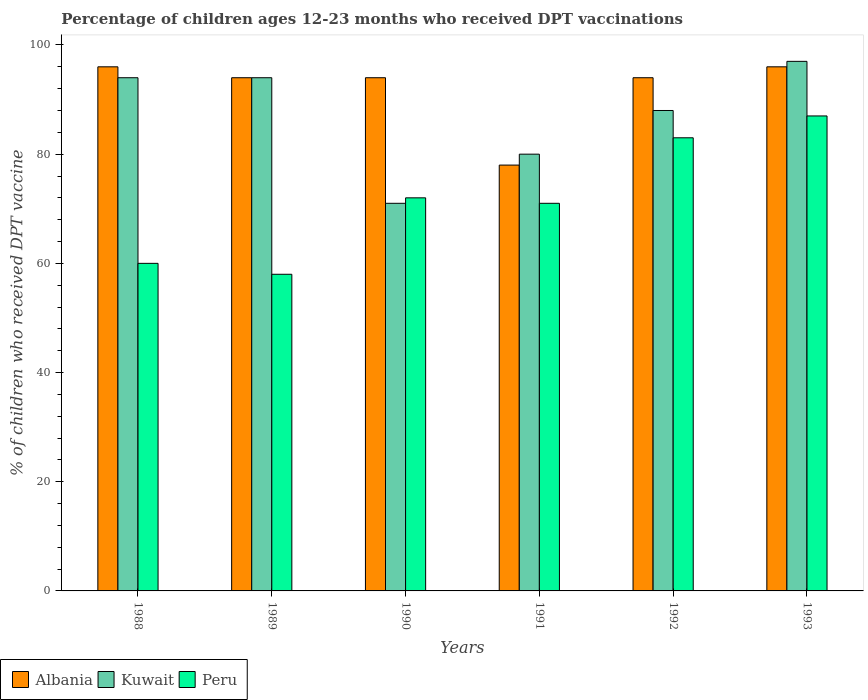How many different coloured bars are there?
Offer a very short reply. 3. How many groups of bars are there?
Offer a very short reply. 6. Are the number of bars per tick equal to the number of legend labels?
Your answer should be compact. Yes. Are the number of bars on each tick of the X-axis equal?
Ensure brevity in your answer.  Yes. How many bars are there on the 4th tick from the right?
Your response must be concise. 3. What is the label of the 1st group of bars from the left?
Keep it short and to the point. 1988. What is the percentage of children who received DPT vaccination in Albania in 1990?
Provide a succinct answer. 94. Across all years, what is the maximum percentage of children who received DPT vaccination in Peru?
Provide a succinct answer. 87. Across all years, what is the minimum percentage of children who received DPT vaccination in Albania?
Offer a terse response. 78. In which year was the percentage of children who received DPT vaccination in Albania maximum?
Offer a very short reply. 1988. In which year was the percentage of children who received DPT vaccination in Albania minimum?
Your answer should be very brief. 1991. What is the total percentage of children who received DPT vaccination in Albania in the graph?
Provide a succinct answer. 552. What is the difference between the percentage of children who received DPT vaccination in Kuwait in 1988 and the percentage of children who received DPT vaccination in Peru in 1990?
Give a very brief answer. 22. What is the average percentage of children who received DPT vaccination in Albania per year?
Provide a succinct answer. 92. In the year 1989, what is the difference between the percentage of children who received DPT vaccination in Albania and percentage of children who received DPT vaccination in Peru?
Give a very brief answer. 36. What is the ratio of the percentage of children who received DPT vaccination in Albania in 1991 to that in 1993?
Give a very brief answer. 0.81. Is the percentage of children who received DPT vaccination in Kuwait in 1990 less than that in 1992?
Provide a succinct answer. Yes. Is the difference between the percentage of children who received DPT vaccination in Albania in 1990 and 1992 greater than the difference between the percentage of children who received DPT vaccination in Peru in 1990 and 1992?
Offer a terse response. Yes. What is the difference between the highest and the second highest percentage of children who received DPT vaccination in Kuwait?
Offer a terse response. 3. What is the difference between the highest and the lowest percentage of children who received DPT vaccination in Kuwait?
Your response must be concise. 26. In how many years, is the percentage of children who received DPT vaccination in Peru greater than the average percentage of children who received DPT vaccination in Peru taken over all years?
Give a very brief answer. 3. Is the sum of the percentage of children who received DPT vaccination in Peru in 1988 and 1992 greater than the maximum percentage of children who received DPT vaccination in Albania across all years?
Provide a succinct answer. Yes. What does the 2nd bar from the right in 1988 represents?
Ensure brevity in your answer.  Kuwait. Is it the case that in every year, the sum of the percentage of children who received DPT vaccination in Kuwait and percentage of children who received DPT vaccination in Albania is greater than the percentage of children who received DPT vaccination in Peru?
Provide a short and direct response. Yes. How many years are there in the graph?
Give a very brief answer. 6. What is the difference between two consecutive major ticks on the Y-axis?
Provide a short and direct response. 20. Are the values on the major ticks of Y-axis written in scientific E-notation?
Your response must be concise. No. Does the graph contain any zero values?
Give a very brief answer. No. How are the legend labels stacked?
Ensure brevity in your answer.  Horizontal. What is the title of the graph?
Your response must be concise. Percentage of children ages 12-23 months who received DPT vaccinations. Does "Puerto Rico" appear as one of the legend labels in the graph?
Make the answer very short. No. What is the label or title of the X-axis?
Ensure brevity in your answer.  Years. What is the label or title of the Y-axis?
Offer a very short reply. % of children who received DPT vaccine. What is the % of children who received DPT vaccine of Albania in 1988?
Your response must be concise. 96. What is the % of children who received DPT vaccine in Kuwait in 1988?
Your answer should be compact. 94. What is the % of children who received DPT vaccine in Peru in 1988?
Give a very brief answer. 60. What is the % of children who received DPT vaccine of Albania in 1989?
Provide a short and direct response. 94. What is the % of children who received DPT vaccine in Kuwait in 1989?
Your answer should be very brief. 94. What is the % of children who received DPT vaccine in Peru in 1989?
Offer a very short reply. 58. What is the % of children who received DPT vaccine in Albania in 1990?
Offer a terse response. 94. What is the % of children who received DPT vaccine of Albania in 1991?
Provide a succinct answer. 78. What is the % of children who received DPT vaccine in Kuwait in 1991?
Make the answer very short. 80. What is the % of children who received DPT vaccine in Albania in 1992?
Your answer should be compact. 94. What is the % of children who received DPT vaccine in Albania in 1993?
Offer a terse response. 96. What is the % of children who received DPT vaccine of Kuwait in 1993?
Offer a very short reply. 97. What is the % of children who received DPT vaccine of Peru in 1993?
Provide a short and direct response. 87. Across all years, what is the maximum % of children who received DPT vaccine of Albania?
Ensure brevity in your answer.  96. Across all years, what is the maximum % of children who received DPT vaccine of Kuwait?
Keep it short and to the point. 97. Across all years, what is the minimum % of children who received DPT vaccine in Kuwait?
Make the answer very short. 71. Across all years, what is the minimum % of children who received DPT vaccine in Peru?
Your answer should be very brief. 58. What is the total % of children who received DPT vaccine of Albania in the graph?
Make the answer very short. 552. What is the total % of children who received DPT vaccine in Kuwait in the graph?
Provide a succinct answer. 524. What is the total % of children who received DPT vaccine in Peru in the graph?
Make the answer very short. 431. What is the difference between the % of children who received DPT vaccine of Albania in 1988 and that in 1989?
Keep it short and to the point. 2. What is the difference between the % of children who received DPT vaccine of Kuwait in 1988 and that in 1989?
Keep it short and to the point. 0. What is the difference between the % of children who received DPT vaccine of Peru in 1988 and that in 1989?
Provide a short and direct response. 2. What is the difference between the % of children who received DPT vaccine in Kuwait in 1988 and that in 1990?
Give a very brief answer. 23. What is the difference between the % of children who received DPT vaccine of Peru in 1988 and that in 1990?
Your response must be concise. -12. What is the difference between the % of children who received DPT vaccine of Albania in 1988 and that in 1991?
Keep it short and to the point. 18. What is the difference between the % of children who received DPT vaccine in Peru in 1988 and that in 1991?
Give a very brief answer. -11. What is the difference between the % of children who received DPT vaccine in Peru in 1988 and that in 1993?
Give a very brief answer. -27. What is the difference between the % of children who received DPT vaccine of Kuwait in 1989 and that in 1990?
Give a very brief answer. 23. What is the difference between the % of children who received DPT vaccine of Albania in 1989 and that in 1991?
Your answer should be compact. 16. What is the difference between the % of children who received DPT vaccine of Kuwait in 1989 and that in 1991?
Make the answer very short. 14. What is the difference between the % of children who received DPT vaccine in Kuwait in 1989 and that in 1992?
Give a very brief answer. 6. What is the difference between the % of children who received DPT vaccine of Peru in 1989 and that in 1993?
Ensure brevity in your answer.  -29. What is the difference between the % of children who received DPT vaccine in Albania in 1990 and that in 1991?
Offer a very short reply. 16. What is the difference between the % of children who received DPT vaccine in Kuwait in 1990 and that in 1991?
Provide a short and direct response. -9. What is the difference between the % of children who received DPT vaccine of Peru in 1990 and that in 1991?
Make the answer very short. 1. What is the difference between the % of children who received DPT vaccine of Albania in 1990 and that in 1993?
Ensure brevity in your answer.  -2. What is the difference between the % of children who received DPT vaccine in Kuwait in 1990 and that in 1993?
Give a very brief answer. -26. What is the difference between the % of children who received DPT vaccine in Albania in 1991 and that in 1992?
Offer a very short reply. -16. What is the difference between the % of children who received DPT vaccine in Kuwait in 1991 and that in 1992?
Your answer should be very brief. -8. What is the difference between the % of children who received DPT vaccine in Peru in 1991 and that in 1992?
Provide a succinct answer. -12. What is the difference between the % of children who received DPT vaccine in Kuwait in 1991 and that in 1993?
Give a very brief answer. -17. What is the difference between the % of children who received DPT vaccine in Peru in 1991 and that in 1993?
Your answer should be compact. -16. What is the difference between the % of children who received DPT vaccine in Albania in 1992 and that in 1993?
Make the answer very short. -2. What is the difference between the % of children who received DPT vaccine in Albania in 1988 and the % of children who received DPT vaccine in Peru in 1989?
Your response must be concise. 38. What is the difference between the % of children who received DPT vaccine in Kuwait in 1988 and the % of children who received DPT vaccine in Peru in 1989?
Your answer should be very brief. 36. What is the difference between the % of children who received DPT vaccine in Albania in 1988 and the % of children who received DPT vaccine in Kuwait in 1990?
Offer a terse response. 25. What is the difference between the % of children who received DPT vaccine in Albania in 1988 and the % of children who received DPT vaccine in Peru in 1990?
Keep it short and to the point. 24. What is the difference between the % of children who received DPT vaccine of Albania in 1988 and the % of children who received DPT vaccine of Peru in 1991?
Make the answer very short. 25. What is the difference between the % of children who received DPT vaccine in Kuwait in 1988 and the % of children who received DPT vaccine in Peru in 1992?
Your answer should be compact. 11. What is the difference between the % of children who received DPT vaccine of Albania in 1988 and the % of children who received DPT vaccine of Kuwait in 1993?
Give a very brief answer. -1. What is the difference between the % of children who received DPT vaccine of Albania in 1989 and the % of children who received DPT vaccine of Kuwait in 1990?
Provide a short and direct response. 23. What is the difference between the % of children who received DPT vaccine of Albania in 1989 and the % of children who received DPT vaccine of Peru in 1990?
Your response must be concise. 22. What is the difference between the % of children who received DPT vaccine of Kuwait in 1989 and the % of children who received DPT vaccine of Peru in 1990?
Offer a very short reply. 22. What is the difference between the % of children who received DPT vaccine of Kuwait in 1989 and the % of children who received DPT vaccine of Peru in 1991?
Keep it short and to the point. 23. What is the difference between the % of children who received DPT vaccine in Albania in 1989 and the % of children who received DPT vaccine in Kuwait in 1992?
Give a very brief answer. 6. What is the difference between the % of children who received DPT vaccine in Albania in 1989 and the % of children who received DPT vaccine in Peru in 1992?
Keep it short and to the point. 11. What is the difference between the % of children who received DPT vaccine in Albania in 1989 and the % of children who received DPT vaccine in Kuwait in 1993?
Ensure brevity in your answer.  -3. What is the difference between the % of children who received DPT vaccine of Albania in 1990 and the % of children who received DPT vaccine of Kuwait in 1991?
Provide a succinct answer. 14. What is the difference between the % of children who received DPT vaccine in Albania in 1990 and the % of children who received DPT vaccine in Peru in 1991?
Your response must be concise. 23. What is the difference between the % of children who received DPT vaccine in Albania in 1990 and the % of children who received DPT vaccine in Kuwait in 1992?
Offer a terse response. 6. What is the difference between the % of children who received DPT vaccine in Albania in 1990 and the % of children who received DPT vaccine in Peru in 1992?
Provide a short and direct response. 11. What is the difference between the % of children who received DPT vaccine in Kuwait in 1990 and the % of children who received DPT vaccine in Peru in 1993?
Keep it short and to the point. -16. What is the difference between the % of children who received DPT vaccine in Albania in 1991 and the % of children who received DPT vaccine in Peru in 1992?
Offer a very short reply. -5. What is the difference between the % of children who received DPT vaccine in Kuwait in 1991 and the % of children who received DPT vaccine in Peru in 1992?
Offer a terse response. -3. What is the difference between the % of children who received DPT vaccine in Kuwait in 1991 and the % of children who received DPT vaccine in Peru in 1993?
Offer a terse response. -7. What is the difference between the % of children who received DPT vaccine of Albania in 1992 and the % of children who received DPT vaccine of Peru in 1993?
Make the answer very short. 7. What is the average % of children who received DPT vaccine in Albania per year?
Ensure brevity in your answer.  92. What is the average % of children who received DPT vaccine in Kuwait per year?
Ensure brevity in your answer.  87.33. What is the average % of children who received DPT vaccine in Peru per year?
Offer a terse response. 71.83. In the year 1988, what is the difference between the % of children who received DPT vaccine in Albania and % of children who received DPT vaccine in Kuwait?
Provide a succinct answer. 2. In the year 1988, what is the difference between the % of children who received DPT vaccine of Albania and % of children who received DPT vaccine of Peru?
Your response must be concise. 36. In the year 1989, what is the difference between the % of children who received DPT vaccine of Albania and % of children who received DPT vaccine of Kuwait?
Offer a terse response. 0. In the year 1989, what is the difference between the % of children who received DPT vaccine of Albania and % of children who received DPT vaccine of Peru?
Keep it short and to the point. 36. In the year 1989, what is the difference between the % of children who received DPT vaccine in Kuwait and % of children who received DPT vaccine in Peru?
Ensure brevity in your answer.  36. In the year 1990, what is the difference between the % of children who received DPT vaccine in Albania and % of children who received DPT vaccine in Kuwait?
Give a very brief answer. 23. In the year 1990, what is the difference between the % of children who received DPT vaccine of Albania and % of children who received DPT vaccine of Peru?
Offer a very short reply. 22. In the year 1990, what is the difference between the % of children who received DPT vaccine of Kuwait and % of children who received DPT vaccine of Peru?
Make the answer very short. -1. In the year 1991, what is the difference between the % of children who received DPT vaccine in Albania and % of children who received DPT vaccine in Kuwait?
Your answer should be very brief. -2. In the year 1992, what is the difference between the % of children who received DPT vaccine in Albania and % of children who received DPT vaccine in Kuwait?
Your response must be concise. 6. In the year 1992, what is the difference between the % of children who received DPT vaccine in Albania and % of children who received DPT vaccine in Peru?
Give a very brief answer. 11. In the year 1992, what is the difference between the % of children who received DPT vaccine in Kuwait and % of children who received DPT vaccine in Peru?
Provide a short and direct response. 5. In the year 1993, what is the difference between the % of children who received DPT vaccine in Albania and % of children who received DPT vaccine in Kuwait?
Give a very brief answer. -1. What is the ratio of the % of children who received DPT vaccine in Albania in 1988 to that in 1989?
Give a very brief answer. 1.02. What is the ratio of the % of children who received DPT vaccine in Peru in 1988 to that in 1989?
Ensure brevity in your answer.  1.03. What is the ratio of the % of children who received DPT vaccine in Albania in 1988 to that in 1990?
Offer a terse response. 1.02. What is the ratio of the % of children who received DPT vaccine of Kuwait in 1988 to that in 1990?
Your response must be concise. 1.32. What is the ratio of the % of children who received DPT vaccine of Albania in 1988 to that in 1991?
Ensure brevity in your answer.  1.23. What is the ratio of the % of children who received DPT vaccine of Kuwait in 1988 to that in 1991?
Keep it short and to the point. 1.18. What is the ratio of the % of children who received DPT vaccine in Peru in 1988 to that in 1991?
Make the answer very short. 0.85. What is the ratio of the % of children who received DPT vaccine of Albania in 1988 to that in 1992?
Give a very brief answer. 1.02. What is the ratio of the % of children who received DPT vaccine of Kuwait in 1988 to that in 1992?
Provide a short and direct response. 1.07. What is the ratio of the % of children who received DPT vaccine of Peru in 1988 to that in 1992?
Your answer should be very brief. 0.72. What is the ratio of the % of children who received DPT vaccine in Kuwait in 1988 to that in 1993?
Provide a succinct answer. 0.97. What is the ratio of the % of children who received DPT vaccine in Peru in 1988 to that in 1993?
Your answer should be compact. 0.69. What is the ratio of the % of children who received DPT vaccine in Kuwait in 1989 to that in 1990?
Ensure brevity in your answer.  1.32. What is the ratio of the % of children who received DPT vaccine in Peru in 1989 to that in 1990?
Make the answer very short. 0.81. What is the ratio of the % of children who received DPT vaccine in Albania in 1989 to that in 1991?
Offer a terse response. 1.21. What is the ratio of the % of children who received DPT vaccine in Kuwait in 1989 to that in 1991?
Give a very brief answer. 1.18. What is the ratio of the % of children who received DPT vaccine in Peru in 1989 to that in 1991?
Keep it short and to the point. 0.82. What is the ratio of the % of children who received DPT vaccine of Kuwait in 1989 to that in 1992?
Provide a succinct answer. 1.07. What is the ratio of the % of children who received DPT vaccine of Peru in 1989 to that in 1992?
Provide a short and direct response. 0.7. What is the ratio of the % of children who received DPT vaccine in Albania in 1989 to that in 1993?
Make the answer very short. 0.98. What is the ratio of the % of children who received DPT vaccine of Kuwait in 1989 to that in 1993?
Provide a succinct answer. 0.97. What is the ratio of the % of children who received DPT vaccine of Albania in 1990 to that in 1991?
Give a very brief answer. 1.21. What is the ratio of the % of children who received DPT vaccine of Kuwait in 1990 to that in 1991?
Your answer should be compact. 0.89. What is the ratio of the % of children who received DPT vaccine of Peru in 1990 to that in 1991?
Ensure brevity in your answer.  1.01. What is the ratio of the % of children who received DPT vaccine of Albania in 1990 to that in 1992?
Provide a short and direct response. 1. What is the ratio of the % of children who received DPT vaccine in Kuwait in 1990 to that in 1992?
Give a very brief answer. 0.81. What is the ratio of the % of children who received DPT vaccine in Peru in 1990 to that in 1992?
Your answer should be compact. 0.87. What is the ratio of the % of children who received DPT vaccine in Albania in 1990 to that in 1993?
Provide a short and direct response. 0.98. What is the ratio of the % of children who received DPT vaccine of Kuwait in 1990 to that in 1993?
Make the answer very short. 0.73. What is the ratio of the % of children who received DPT vaccine in Peru in 1990 to that in 1993?
Ensure brevity in your answer.  0.83. What is the ratio of the % of children who received DPT vaccine in Albania in 1991 to that in 1992?
Ensure brevity in your answer.  0.83. What is the ratio of the % of children who received DPT vaccine of Kuwait in 1991 to that in 1992?
Offer a very short reply. 0.91. What is the ratio of the % of children who received DPT vaccine in Peru in 1991 to that in 1992?
Keep it short and to the point. 0.86. What is the ratio of the % of children who received DPT vaccine in Albania in 1991 to that in 1993?
Make the answer very short. 0.81. What is the ratio of the % of children who received DPT vaccine of Kuwait in 1991 to that in 1993?
Ensure brevity in your answer.  0.82. What is the ratio of the % of children who received DPT vaccine in Peru in 1991 to that in 1993?
Keep it short and to the point. 0.82. What is the ratio of the % of children who received DPT vaccine in Albania in 1992 to that in 1993?
Provide a succinct answer. 0.98. What is the ratio of the % of children who received DPT vaccine in Kuwait in 1992 to that in 1993?
Offer a terse response. 0.91. What is the ratio of the % of children who received DPT vaccine in Peru in 1992 to that in 1993?
Give a very brief answer. 0.95. What is the difference between the highest and the second highest % of children who received DPT vaccine of Albania?
Give a very brief answer. 0. What is the difference between the highest and the second highest % of children who received DPT vaccine in Peru?
Your answer should be very brief. 4. What is the difference between the highest and the lowest % of children who received DPT vaccine in Kuwait?
Ensure brevity in your answer.  26. 